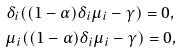<formula> <loc_0><loc_0><loc_500><loc_500>& \delta _ { i } ( ( 1 - \alpha ) \delta _ { i } \mu _ { i } - \gamma ) = 0 , \\ & \mu _ { i } ( ( 1 - \alpha ) \delta _ { i } \mu _ { i } - \gamma ) = 0 ,</formula> 